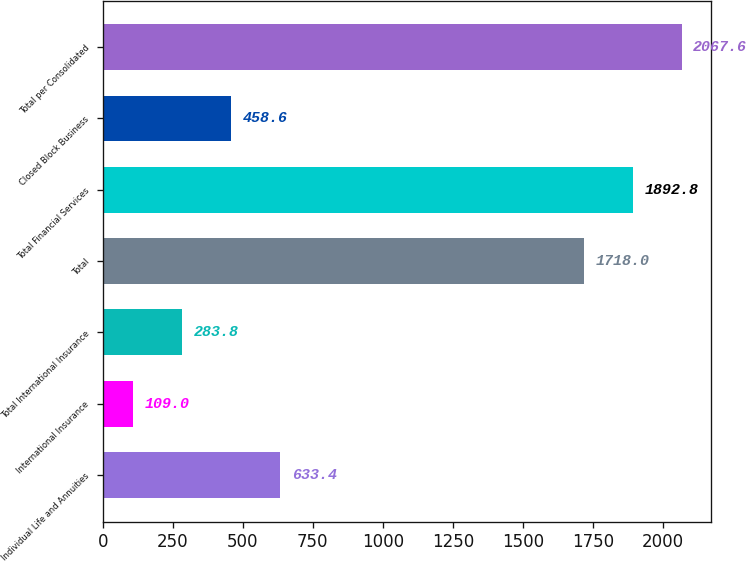Convert chart. <chart><loc_0><loc_0><loc_500><loc_500><bar_chart><fcel>Individual Life and Annuities<fcel>International Insurance<fcel>Total International Insurance<fcel>Total<fcel>Total Financial Services<fcel>Closed Block Business<fcel>Total per Consolidated<nl><fcel>633.4<fcel>109<fcel>283.8<fcel>1718<fcel>1892.8<fcel>458.6<fcel>2067.6<nl></chart> 